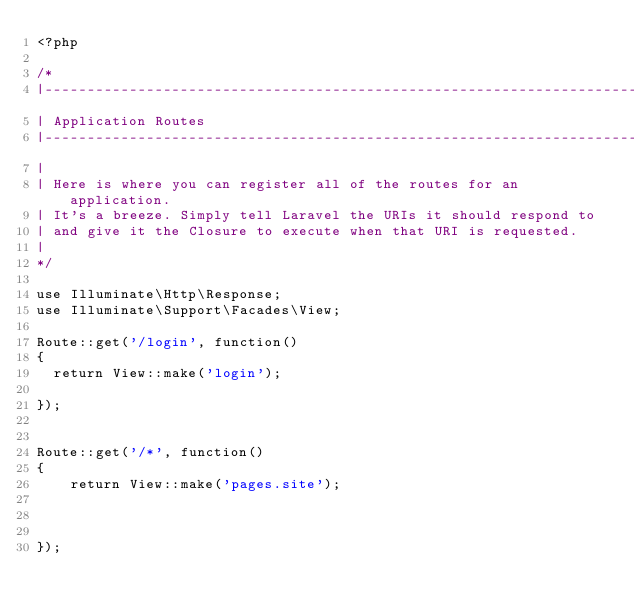<code> <loc_0><loc_0><loc_500><loc_500><_PHP_><?php

/*
|--------------------------------------------------------------------------
| Application Routes
|--------------------------------------------------------------------------
|
| Here is where you can register all of the routes for an application.
| It's a breeze. Simply tell Laravel the URIs it should respond to
| and give it the Closure to execute when that URI is requested.
|
*/

use Illuminate\Http\Response;
use Illuminate\Support\Facades\View;

Route::get('/login', function()
{
  return View::make('login');

});


Route::get('/*', function()
{
    return View::make('pages.site');



});

</code> 